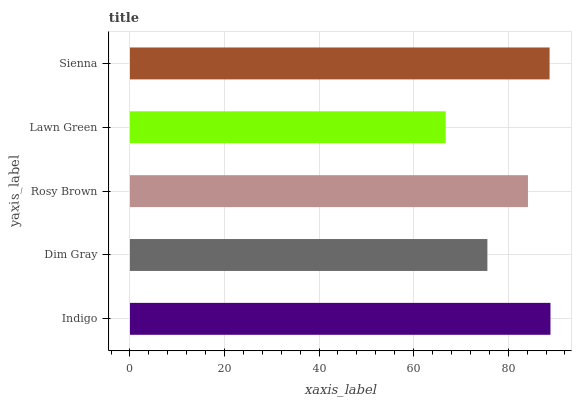Is Lawn Green the minimum?
Answer yes or no. Yes. Is Indigo the maximum?
Answer yes or no. Yes. Is Dim Gray the minimum?
Answer yes or no. No. Is Dim Gray the maximum?
Answer yes or no. No. Is Indigo greater than Dim Gray?
Answer yes or no. Yes. Is Dim Gray less than Indigo?
Answer yes or no. Yes. Is Dim Gray greater than Indigo?
Answer yes or no. No. Is Indigo less than Dim Gray?
Answer yes or no. No. Is Rosy Brown the high median?
Answer yes or no. Yes. Is Rosy Brown the low median?
Answer yes or no. Yes. Is Lawn Green the high median?
Answer yes or no. No. Is Sienna the low median?
Answer yes or no. No. 